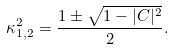<formula> <loc_0><loc_0><loc_500><loc_500>\kappa _ { 1 , 2 } ^ { 2 } = \frac { 1 \pm \sqrt { 1 - | C | ^ { 2 } } } { 2 } .</formula> 